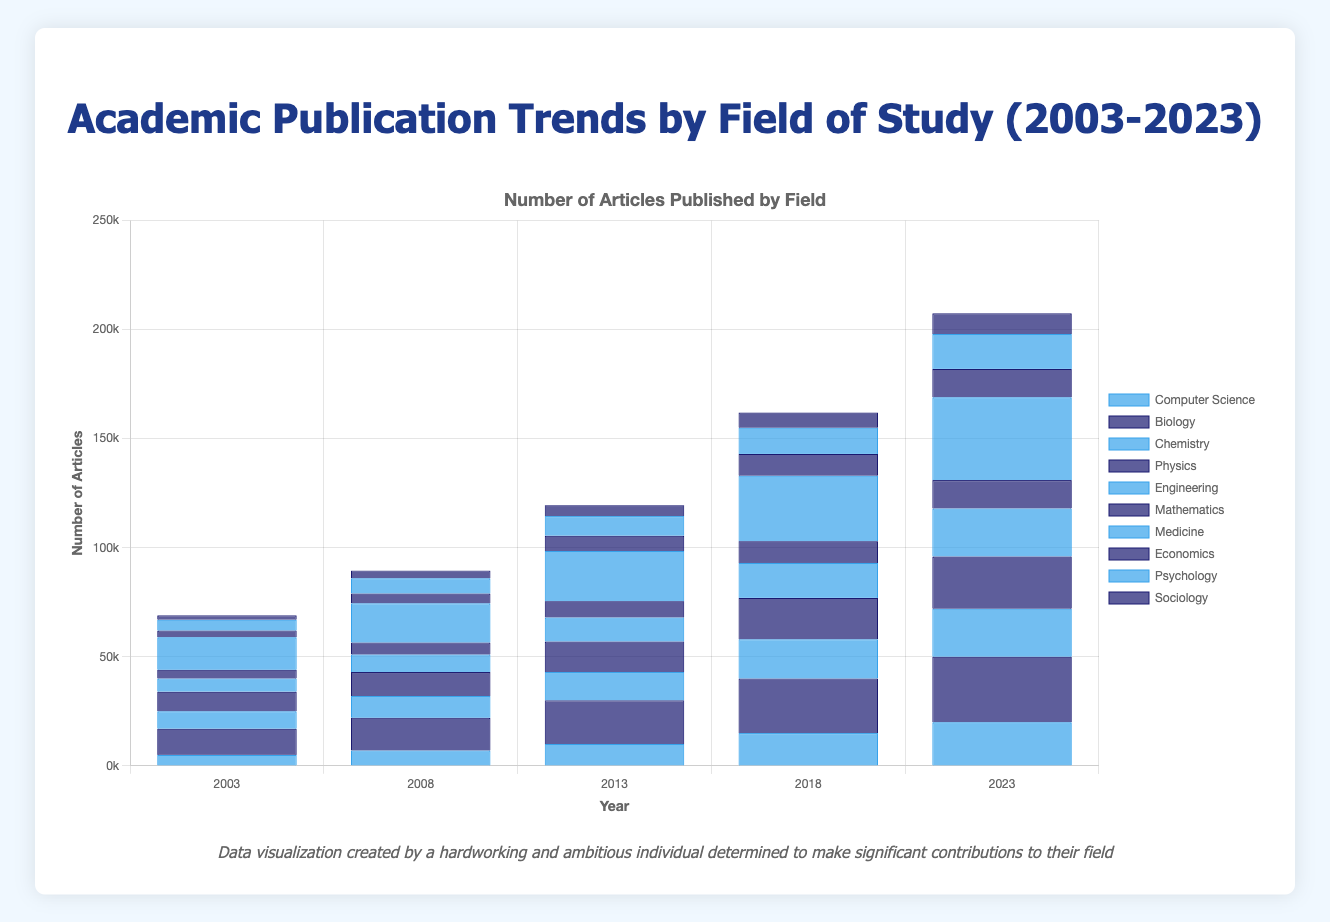Which field of study saw the highest increase in the number of articles published from 2003 to 2023? To find which field saw the highest increase, we subtract the number of articles in 2003 from the number in 2023 for each field, and then compare these differences. For instance, Computer Science: 20000 - 5000 = 15000, Biology: 30000 - 12000 = 18000. By calculating and comparing this for all fields, we see that Medicine had the largest increase (23000).
Answer: Medicine Which two fields had almost the same number of articles published in 2013, and how close were their number of articles? By looking at the bars for 2013, we see Chemistry had 13000 and Physics had 14000 articles published. The difference is 1000 articles.
Answer: Chemistry and Physics, 1000 articles In 2023, which field had more articles published: Psychology or Engineering, and by how much? We compare the height of the bars for Psychology (16000) and Engineering (22000) in 2023. Engineering has more articles. The difference is 22000 - 16000 = 6000 articles.
Answer: Engineering, 6000 articles What is the total number of articles published across all fields in the year 2018? Sum the number of articles from each field in 2018. Computer Science: 15000, Biology: 25000, Chemistry: 18000, Physics: 19000, Engineering: 16000, Mathematics: 10000, Medicine: 30000, Economics: 10000, Psychology: 12000, Sociology: 7000. Total: 15000+25000+18000+19000+16000+10000+30000+10000+12000+7000 = 162000 articles.
Answer: 162000 Which field of study had the least number of citations in 2023? By comparing the bars representing citations, we find Sociology had the least with 75000 citations.
Answer: Sociology How many more articles were published in Biology in 2023 compared to 2003? Subtract the number of articles published in Biology in 2003 from those in 2023: 30000 - 12000 = 18000 articles.
Answer: 18000 articles Which field saw the highest number of published articles in 2008 and how many? By observing the bar heights for 2008, Medicine had the highest with 18000 articles published.
Answer: Medicine, 18000 articles What is the average number of articles published in Mathematics over the five years presented? Add the number of articles for each year and divide by 5: (4000 + 5500 + 7500 + 10000 + 13000) / 5 = 8000 articles.
Answer: 8000 articles 